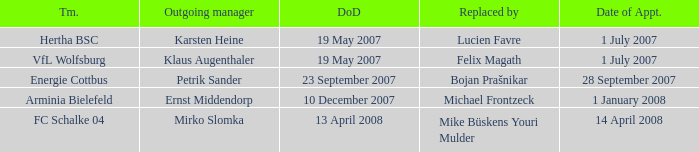When was the appointment date for VFL Wolfsburg? 1 July 2007. 